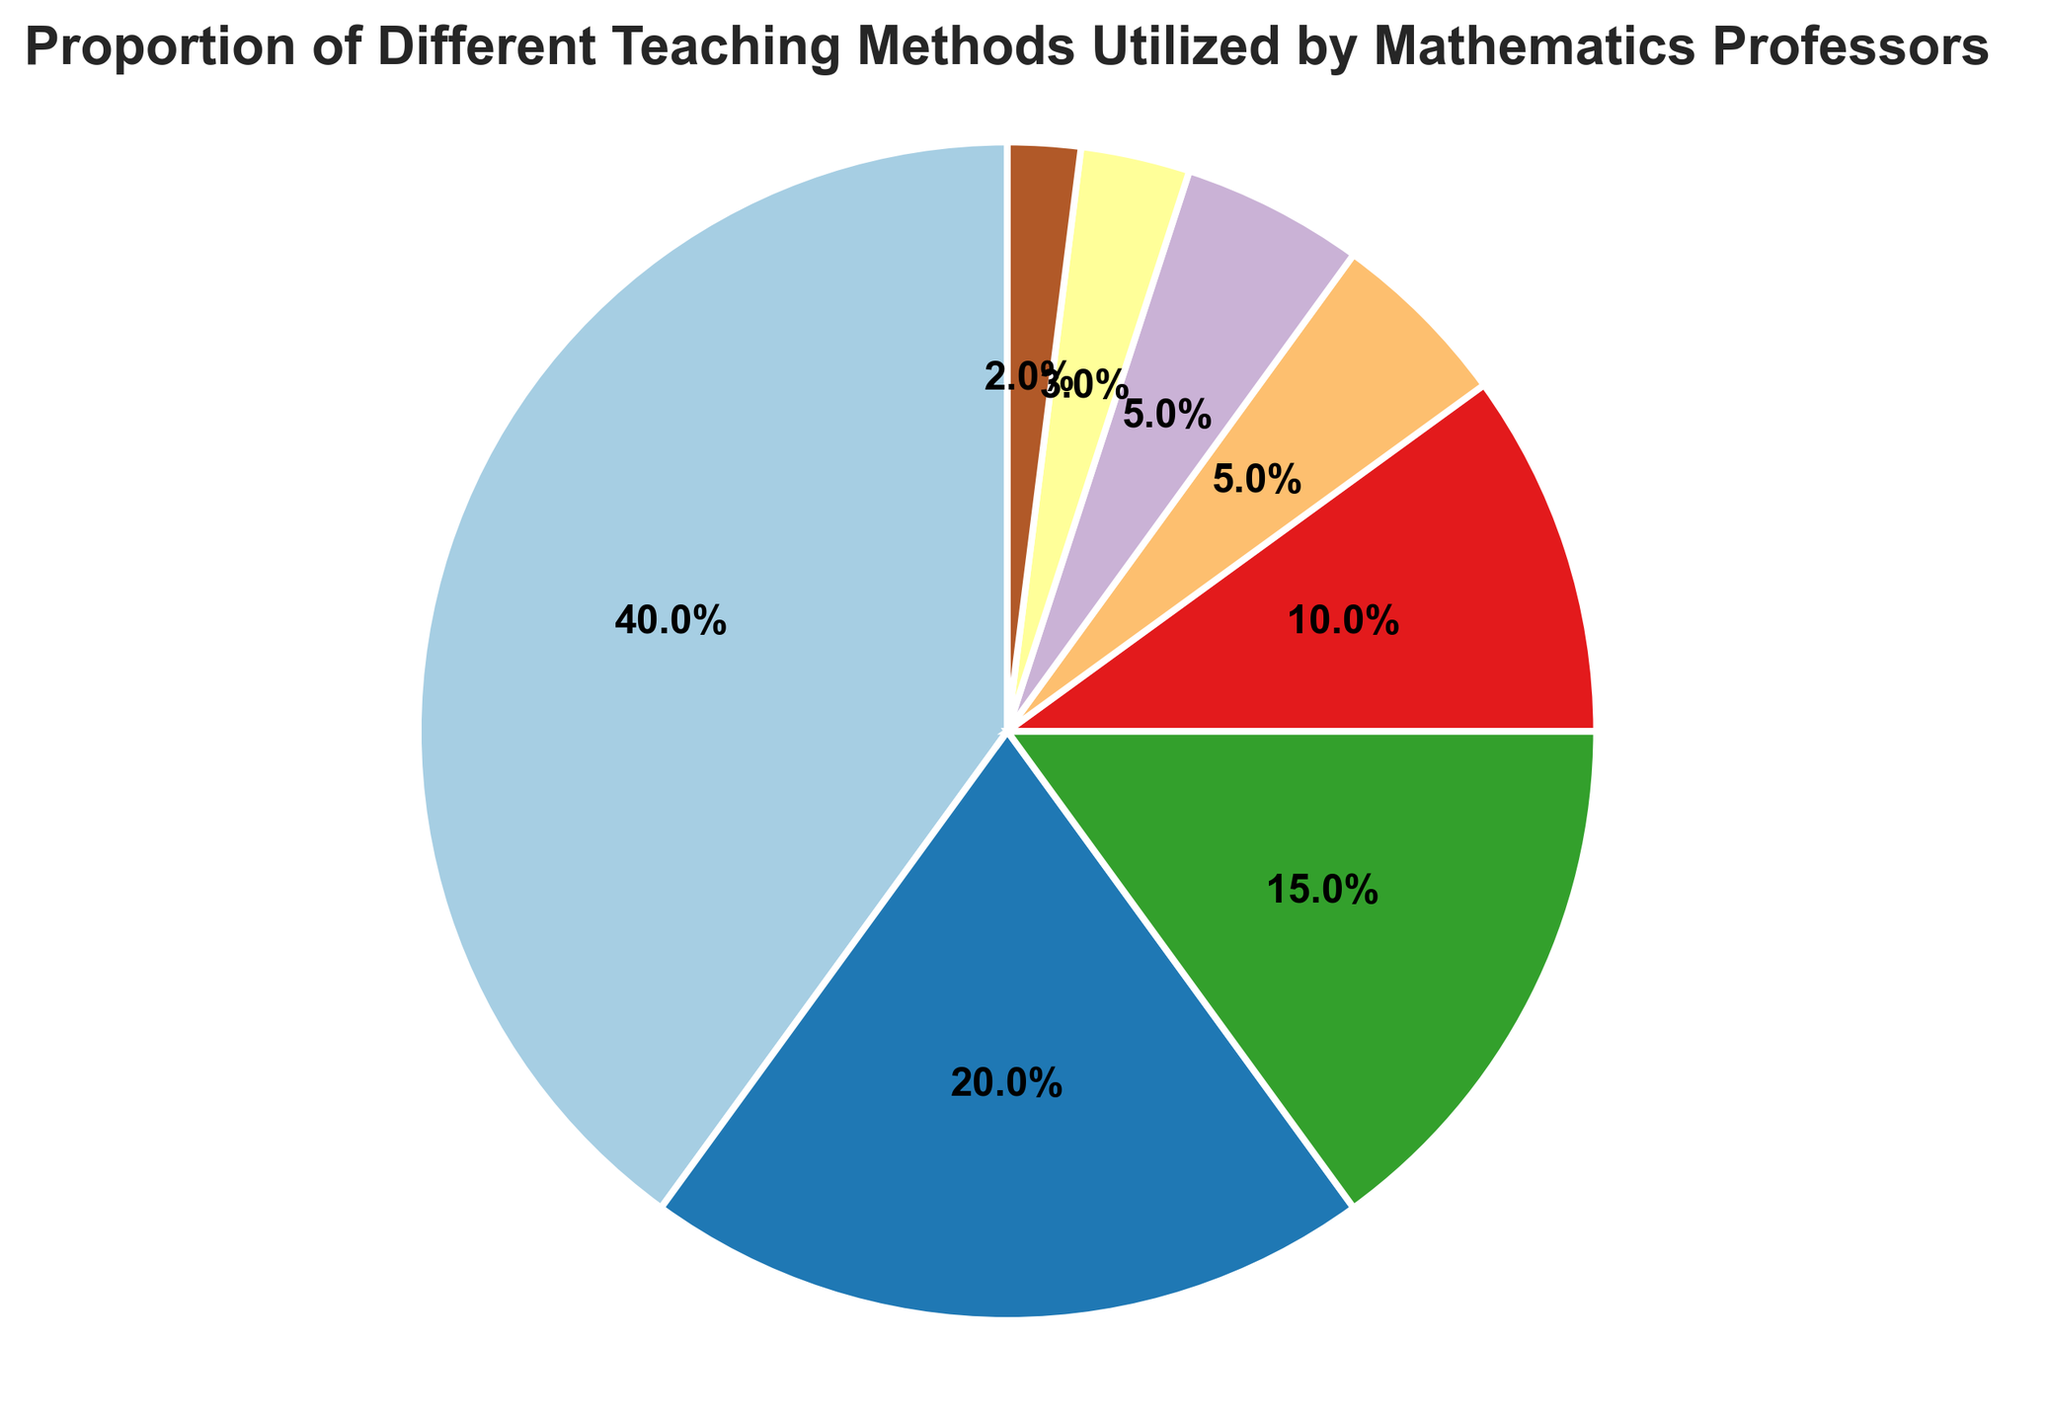Which teaching method has the largest proportion? By visually inspecting the pie chart, we can observe that the segment labeled "Lecture-Based" occupies the most significant portion of the chart.
Answer: Lecture-Based Which method is utilized less, Project-Based Learning or Technology-Enhanced Learning? From the pie chart, both Project-Based Learning and Technology-Enhanced Learning seem nearly identical in size. Each has the same percentage shown in the pie chart as 5.0%.
Answer: Both are utilized equally What's the total proportion represented by Flipped Classroom, Collaborative Learning, and Project-Based Learning combined? To find the combined proportion, we add the percentages of these methods together: 15% (Flipped Classroom) + 10% (Collaborative Learning) + 5% (Project-Based Learning) = 30%.
Answer: 30% How does the proportion of Problem-Based Learning compare to the combined proportion of Discovery Learning and Other? Problem-Based Learning has a proportion of 20%. Discovery Learning is 3%, and Other is 2%. Adding the latter two gives us 5% (3% + 2%). Therefore, Problem-Based Learning is much higher.
Answer: Problem-Based Learning is greater Which teaching method occupies a smaller visual segment: Discovery Learning or Collaborative Learning? By closely observing the pie chart, the segment for Discovery Learning is smaller than that for Collaborative Learning.
Answer: Discovery Learning What is the combined proportion of all teaching methods except Lecture-Based and Problem-Based Learning? Exclude Lecture-Based (40%) and Problem-Based Learning (20%) and add the remaining proportions: Flipped Classroom (15%) + Collaborative Learning (10%) + Project-Based Learning (5%) + Technology-Enhanced Learning (5%) + Discovery Learning (3%) + Other (2%) = 40%.
Answer: 40% If we grouped Technology-Enhanced Learning, Discovery Learning, and Other into one category, what would be its proportion compared to Problem-Based Learning? Combining Technology-Enhanced Learning (5%), Discovery Learning (3%), and Other (2%) results in 10%. Problem-Based Learning alone is 20%. Therefore, Problem-Based Learning is twice as large.
Answer: Problem-Based Learning is larger What is the percentage difference between Flipped Classroom and Collaborative Learning? The proportion for Flipped Classroom is 15%, and for Collaborative Learning, it is 10%. The percentage difference is 15% - 10% = 5%.
Answer: 5% Which two methods, when combined, have a proportion close to Lecture-Based? Lecture-Based has 40%. By combining Problem-Based Learning (20%) and Flipped Classroom (15%), we get 35%, and adding Collaborative Learning (10%) gives 45%. Therefore, Problem-Based Learning and Flipped Classroom combined (35%) are the closest but still not exactly 40%.
Answer: Problem-Based Learning and Flipped Classroom Compared to Project-Based Learning, what is the ratio of Lecture-Based Learning's proportion? Lecture-Based Learning has a proportion of 0.40 (40%), and Project-Based Learning has 0.05 (5%). The ratio is 0.40 / 0.05 = 8.
Answer: 8 